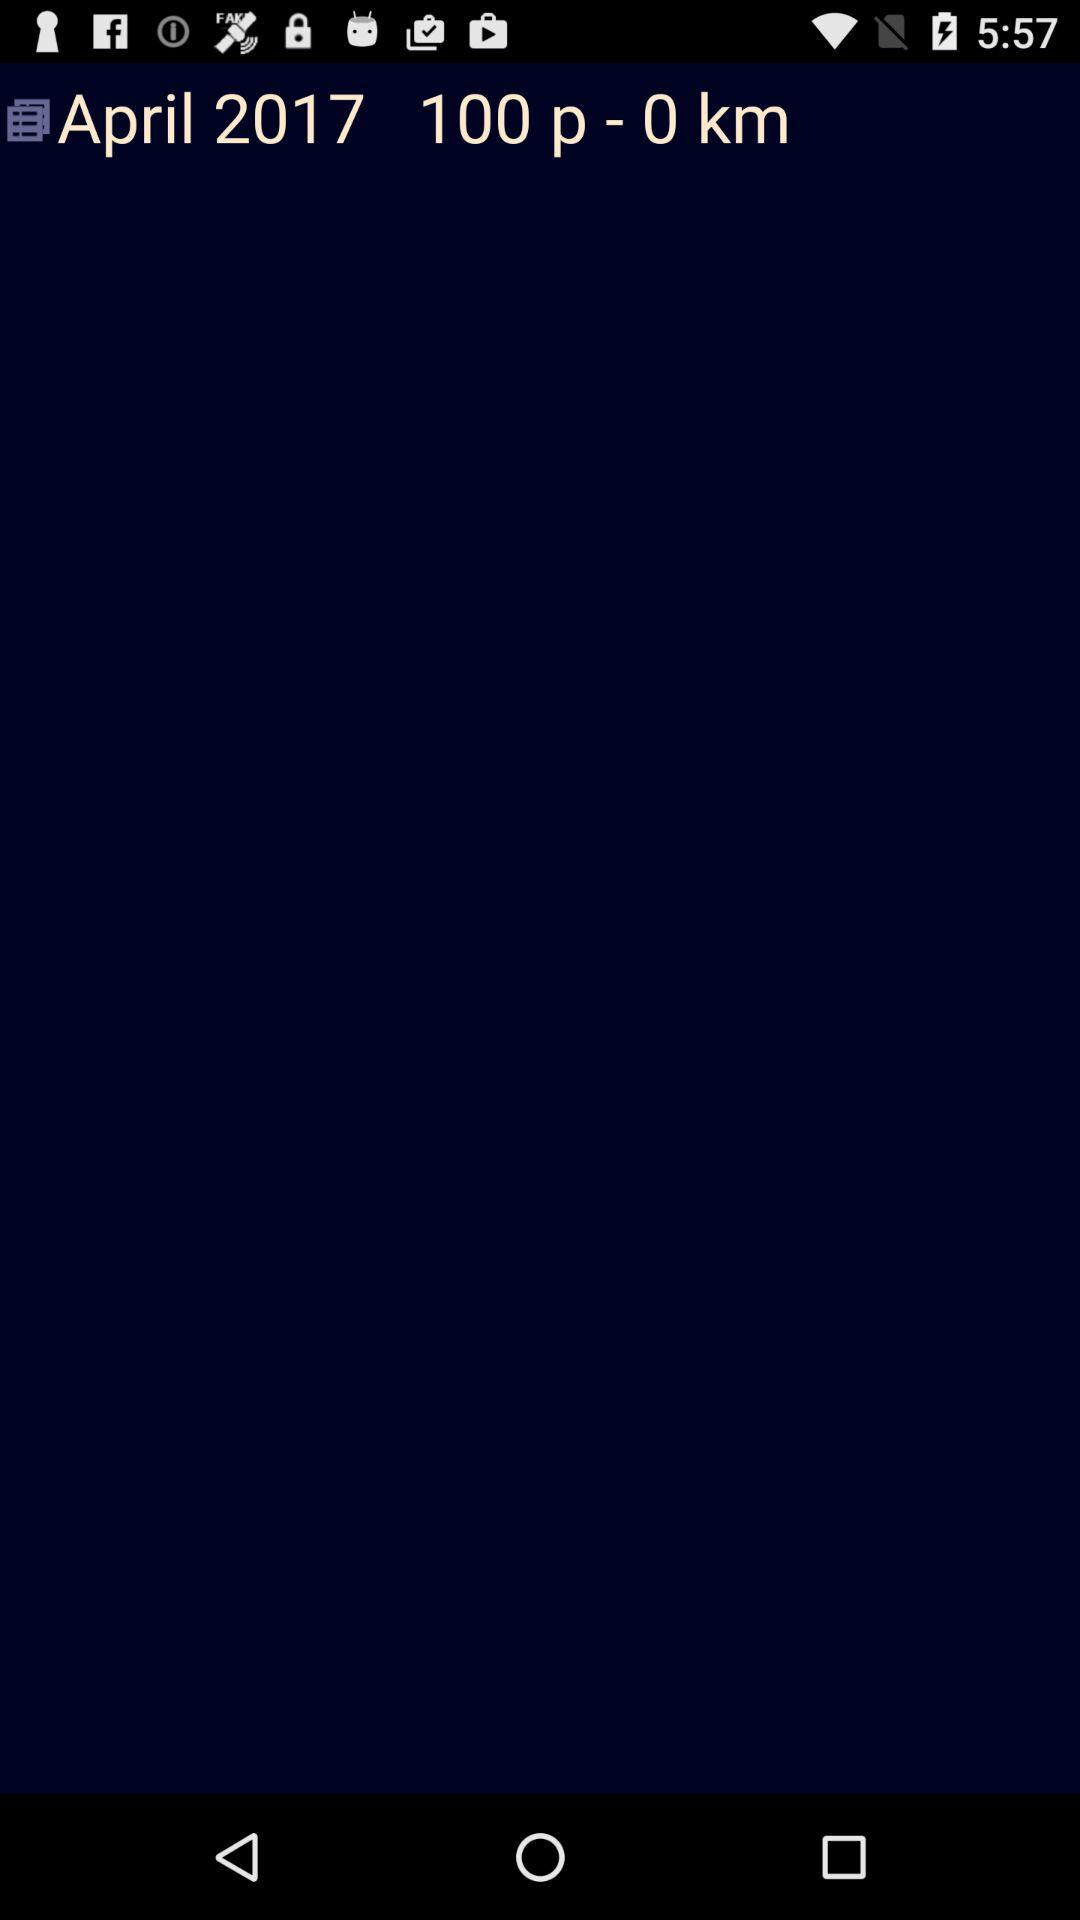What is the given month? The given month is April. 